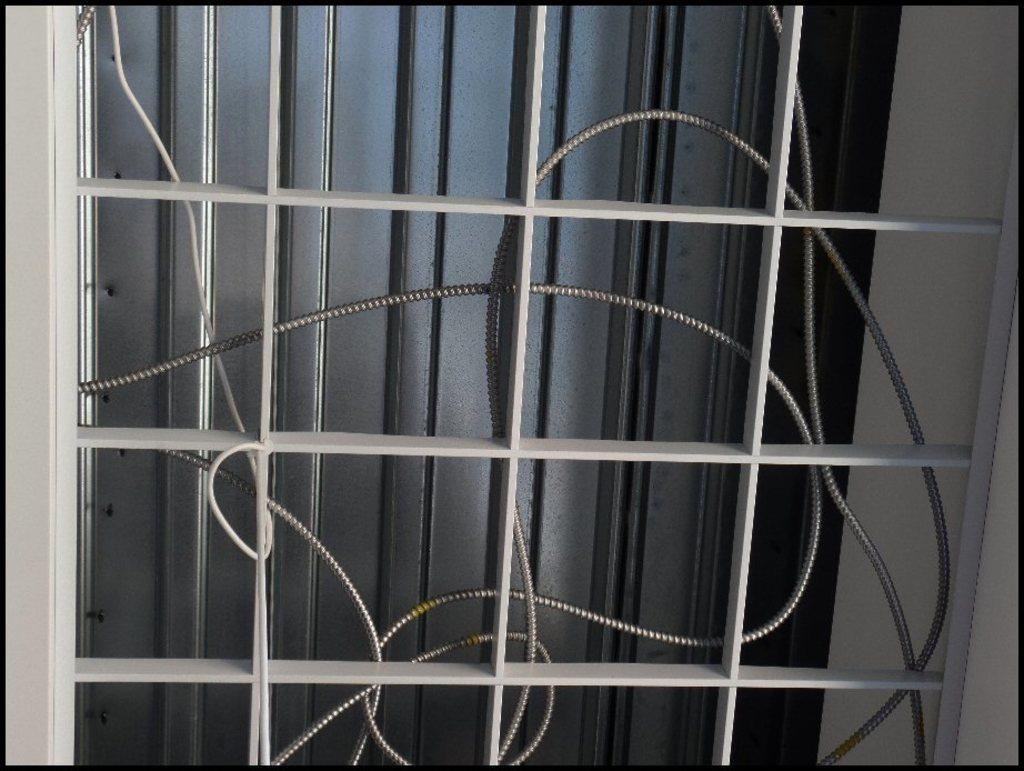What is the main object visible in the image? There is a wire in the image. Can you describe the location of the pipe in the image? The pipe is behind a window in the image. What material is the object at the back of the image made of? The metal object at the back of the image is made of metal. How many accounts are visible in the image? There are no accounts visible in the image. What type of wrench is being used to pull the wire in the image? There is no wrench or pulling action visible in the image; it only shows a wire, a pipe behind a window, and a metal object at the back. 